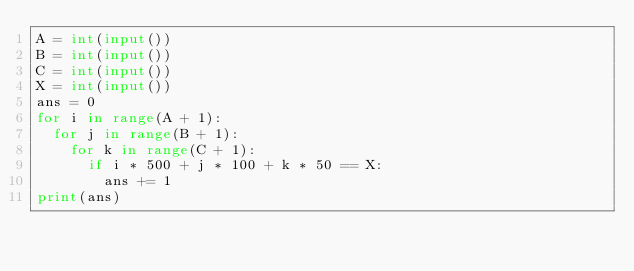Convert code to text. <code><loc_0><loc_0><loc_500><loc_500><_Python_>A = int(input())
B = int(input())
C = int(input())
X = int(input())
ans = 0
for i in range(A + 1):
  for j in range(B + 1):
    for k in range(C + 1):
      if i * 500 + j * 100 + k * 50 == X:
        ans += 1
print(ans)</code> 